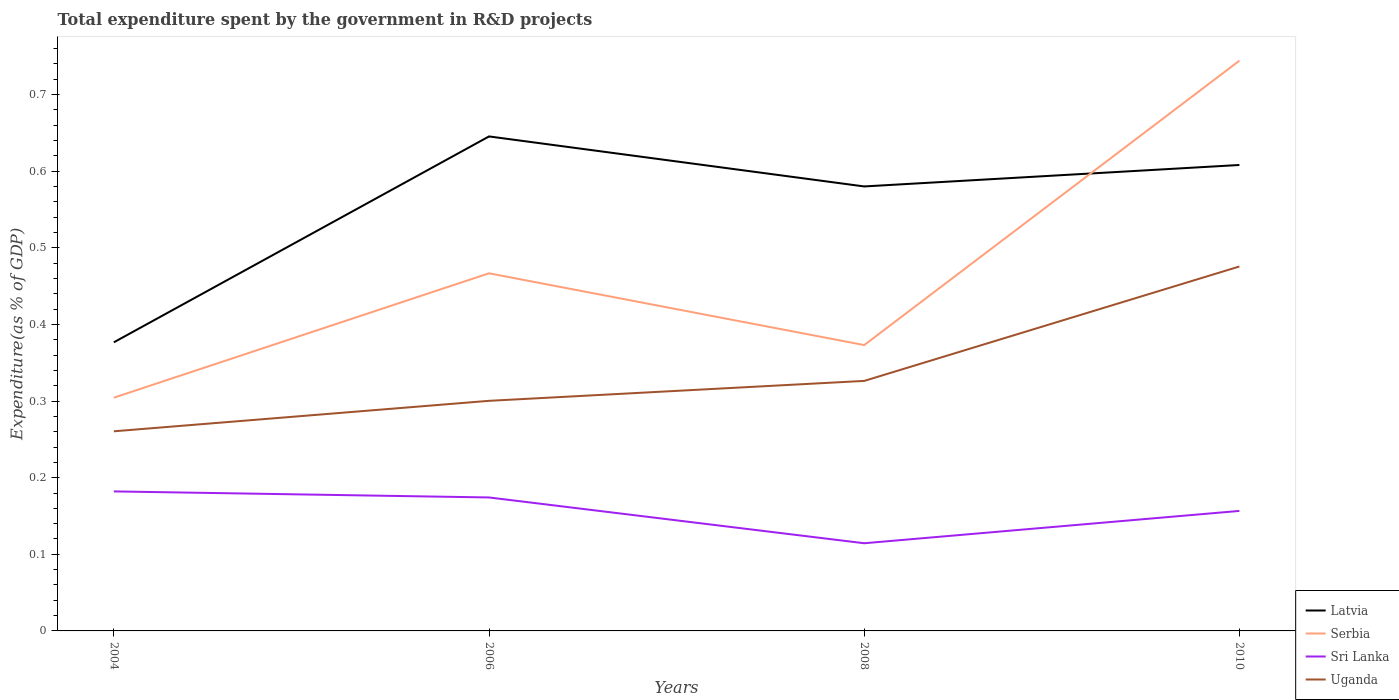How many different coloured lines are there?
Offer a terse response. 4. Does the line corresponding to Serbia intersect with the line corresponding to Latvia?
Provide a short and direct response. Yes. Across all years, what is the maximum total expenditure spent by the government in R&D projects in Serbia?
Make the answer very short. 0.3. What is the total total expenditure spent by the government in R&D projects in Uganda in the graph?
Provide a short and direct response. -0.15. What is the difference between the highest and the second highest total expenditure spent by the government in R&D projects in Serbia?
Offer a very short reply. 0.44. How many lines are there?
Give a very brief answer. 4. How many years are there in the graph?
Your response must be concise. 4. What is the difference between two consecutive major ticks on the Y-axis?
Give a very brief answer. 0.1. Are the values on the major ticks of Y-axis written in scientific E-notation?
Ensure brevity in your answer.  No. Does the graph contain any zero values?
Your answer should be very brief. No. Does the graph contain grids?
Offer a terse response. No. How many legend labels are there?
Your answer should be compact. 4. What is the title of the graph?
Your answer should be compact. Total expenditure spent by the government in R&D projects. Does "Guyana" appear as one of the legend labels in the graph?
Give a very brief answer. No. What is the label or title of the X-axis?
Your answer should be compact. Years. What is the label or title of the Y-axis?
Ensure brevity in your answer.  Expenditure(as % of GDP). What is the Expenditure(as % of GDP) of Latvia in 2004?
Your response must be concise. 0.38. What is the Expenditure(as % of GDP) of Serbia in 2004?
Ensure brevity in your answer.  0.3. What is the Expenditure(as % of GDP) of Sri Lanka in 2004?
Offer a terse response. 0.18. What is the Expenditure(as % of GDP) of Uganda in 2004?
Offer a very short reply. 0.26. What is the Expenditure(as % of GDP) in Latvia in 2006?
Offer a very short reply. 0.65. What is the Expenditure(as % of GDP) of Serbia in 2006?
Make the answer very short. 0.47. What is the Expenditure(as % of GDP) in Sri Lanka in 2006?
Your answer should be compact. 0.17. What is the Expenditure(as % of GDP) in Uganda in 2006?
Your answer should be compact. 0.3. What is the Expenditure(as % of GDP) in Latvia in 2008?
Provide a succinct answer. 0.58. What is the Expenditure(as % of GDP) of Serbia in 2008?
Offer a very short reply. 0.37. What is the Expenditure(as % of GDP) of Sri Lanka in 2008?
Offer a terse response. 0.11. What is the Expenditure(as % of GDP) of Uganda in 2008?
Provide a short and direct response. 0.33. What is the Expenditure(as % of GDP) in Latvia in 2010?
Provide a short and direct response. 0.61. What is the Expenditure(as % of GDP) in Serbia in 2010?
Offer a very short reply. 0.74. What is the Expenditure(as % of GDP) in Sri Lanka in 2010?
Give a very brief answer. 0.16. What is the Expenditure(as % of GDP) in Uganda in 2010?
Your answer should be compact. 0.48. Across all years, what is the maximum Expenditure(as % of GDP) in Latvia?
Your answer should be very brief. 0.65. Across all years, what is the maximum Expenditure(as % of GDP) in Serbia?
Give a very brief answer. 0.74. Across all years, what is the maximum Expenditure(as % of GDP) in Sri Lanka?
Provide a succinct answer. 0.18. Across all years, what is the maximum Expenditure(as % of GDP) in Uganda?
Your response must be concise. 0.48. Across all years, what is the minimum Expenditure(as % of GDP) of Latvia?
Offer a very short reply. 0.38. Across all years, what is the minimum Expenditure(as % of GDP) of Serbia?
Your response must be concise. 0.3. Across all years, what is the minimum Expenditure(as % of GDP) in Sri Lanka?
Make the answer very short. 0.11. Across all years, what is the minimum Expenditure(as % of GDP) of Uganda?
Your answer should be very brief. 0.26. What is the total Expenditure(as % of GDP) of Latvia in the graph?
Offer a terse response. 2.21. What is the total Expenditure(as % of GDP) of Serbia in the graph?
Offer a terse response. 1.89. What is the total Expenditure(as % of GDP) in Sri Lanka in the graph?
Offer a very short reply. 0.63. What is the total Expenditure(as % of GDP) of Uganda in the graph?
Give a very brief answer. 1.36. What is the difference between the Expenditure(as % of GDP) of Latvia in 2004 and that in 2006?
Keep it short and to the point. -0.27. What is the difference between the Expenditure(as % of GDP) in Serbia in 2004 and that in 2006?
Offer a very short reply. -0.16. What is the difference between the Expenditure(as % of GDP) in Sri Lanka in 2004 and that in 2006?
Keep it short and to the point. 0.01. What is the difference between the Expenditure(as % of GDP) of Uganda in 2004 and that in 2006?
Offer a very short reply. -0.04. What is the difference between the Expenditure(as % of GDP) of Latvia in 2004 and that in 2008?
Offer a very short reply. -0.2. What is the difference between the Expenditure(as % of GDP) of Serbia in 2004 and that in 2008?
Provide a succinct answer. -0.07. What is the difference between the Expenditure(as % of GDP) of Sri Lanka in 2004 and that in 2008?
Your answer should be compact. 0.07. What is the difference between the Expenditure(as % of GDP) of Uganda in 2004 and that in 2008?
Ensure brevity in your answer.  -0.07. What is the difference between the Expenditure(as % of GDP) of Latvia in 2004 and that in 2010?
Ensure brevity in your answer.  -0.23. What is the difference between the Expenditure(as % of GDP) in Serbia in 2004 and that in 2010?
Keep it short and to the point. -0.44. What is the difference between the Expenditure(as % of GDP) of Sri Lanka in 2004 and that in 2010?
Your response must be concise. 0.03. What is the difference between the Expenditure(as % of GDP) in Uganda in 2004 and that in 2010?
Offer a terse response. -0.22. What is the difference between the Expenditure(as % of GDP) in Latvia in 2006 and that in 2008?
Offer a very short reply. 0.07. What is the difference between the Expenditure(as % of GDP) of Serbia in 2006 and that in 2008?
Your response must be concise. 0.09. What is the difference between the Expenditure(as % of GDP) of Sri Lanka in 2006 and that in 2008?
Your response must be concise. 0.06. What is the difference between the Expenditure(as % of GDP) of Uganda in 2006 and that in 2008?
Your response must be concise. -0.03. What is the difference between the Expenditure(as % of GDP) of Latvia in 2006 and that in 2010?
Offer a very short reply. 0.04. What is the difference between the Expenditure(as % of GDP) in Serbia in 2006 and that in 2010?
Your answer should be compact. -0.28. What is the difference between the Expenditure(as % of GDP) in Sri Lanka in 2006 and that in 2010?
Keep it short and to the point. 0.02. What is the difference between the Expenditure(as % of GDP) in Uganda in 2006 and that in 2010?
Offer a very short reply. -0.18. What is the difference between the Expenditure(as % of GDP) of Latvia in 2008 and that in 2010?
Provide a succinct answer. -0.03. What is the difference between the Expenditure(as % of GDP) in Serbia in 2008 and that in 2010?
Your answer should be compact. -0.37. What is the difference between the Expenditure(as % of GDP) of Sri Lanka in 2008 and that in 2010?
Make the answer very short. -0.04. What is the difference between the Expenditure(as % of GDP) in Uganda in 2008 and that in 2010?
Provide a short and direct response. -0.15. What is the difference between the Expenditure(as % of GDP) of Latvia in 2004 and the Expenditure(as % of GDP) of Serbia in 2006?
Your response must be concise. -0.09. What is the difference between the Expenditure(as % of GDP) in Latvia in 2004 and the Expenditure(as % of GDP) in Sri Lanka in 2006?
Your response must be concise. 0.2. What is the difference between the Expenditure(as % of GDP) in Latvia in 2004 and the Expenditure(as % of GDP) in Uganda in 2006?
Ensure brevity in your answer.  0.08. What is the difference between the Expenditure(as % of GDP) in Serbia in 2004 and the Expenditure(as % of GDP) in Sri Lanka in 2006?
Give a very brief answer. 0.13. What is the difference between the Expenditure(as % of GDP) in Serbia in 2004 and the Expenditure(as % of GDP) in Uganda in 2006?
Ensure brevity in your answer.  0. What is the difference between the Expenditure(as % of GDP) in Sri Lanka in 2004 and the Expenditure(as % of GDP) in Uganda in 2006?
Offer a very short reply. -0.12. What is the difference between the Expenditure(as % of GDP) in Latvia in 2004 and the Expenditure(as % of GDP) in Serbia in 2008?
Your answer should be very brief. 0. What is the difference between the Expenditure(as % of GDP) in Latvia in 2004 and the Expenditure(as % of GDP) in Sri Lanka in 2008?
Give a very brief answer. 0.26. What is the difference between the Expenditure(as % of GDP) in Latvia in 2004 and the Expenditure(as % of GDP) in Uganda in 2008?
Provide a short and direct response. 0.05. What is the difference between the Expenditure(as % of GDP) in Serbia in 2004 and the Expenditure(as % of GDP) in Sri Lanka in 2008?
Your answer should be compact. 0.19. What is the difference between the Expenditure(as % of GDP) of Serbia in 2004 and the Expenditure(as % of GDP) of Uganda in 2008?
Your answer should be very brief. -0.02. What is the difference between the Expenditure(as % of GDP) of Sri Lanka in 2004 and the Expenditure(as % of GDP) of Uganda in 2008?
Offer a very short reply. -0.14. What is the difference between the Expenditure(as % of GDP) of Latvia in 2004 and the Expenditure(as % of GDP) of Serbia in 2010?
Your answer should be compact. -0.37. What is the difference between the Expenditure(as % of GDP) in Latvia in 2004 and the Expenditure(as % of GDP) in Sri Lanka in 2010?
Offer a very short reply. 0.22. What is the difference between the Expenditure(as % of GDP) in Latvia in 2004 and the Expenditure(as % of GDP) in Uganda in 2010?
Your answer should be compact. -0.1. What is the difference between the Expenditure(as % of GDP) in Serbia in 2004 and the Expenditure(as % of GDP) in Sri Lanka in 2010?
Give a very brief answer. 0.15. What is the difference between the Expenditure(as % of GDP) in Serbia in 2004 and the Expenditure(as % of GDP) in Uganda in 2010?
Your answer should be compact. -0.17. What is the difference between the Expenditure(as % of GDP) of Sri Lanka in 2004 and the Expenditure(as % of GDP) of Uganda in 2010?
Your answer should be very brief. -0.29. What is the difference between the Expenditure(as % of GDP) in Latvia in 2006 and the Expenditure(as % of GDP) in Serbia in 2008?
Provide a succinct answer. 0.27. What is the difference between the Expenditure(as % of GDP) in Latvia in 2006 and the Expenditure(as % of GDP) in Sri Lanka in 2008?
Make the answer very short. 0.53. What is the difference between the Expenditure(as % of GDP) in Latvia in 2006 and the Expenditure(as % of GDP) in Uganda in 2008?
Your answer should be very brief. 0.32. What is the difference between the Expenditure(as % of GDP) of Serbia in 2006 and the Expenditure(as % of GDP) of Sri Lanka in 2008?
Keep it short and to the point. 0.35. What is the difference between the Expenditure(as % of GDP) in Serbia in 2006 and the Expenditure(as % of GDP) in Uganda in 2008?
Offer a terse response. 0.14. What is the difference between the Expenditure(as % of GDP) in Sri Lanka in 2006 and the Expenditure(as % of GDP) in Uganda in 2008?
Keep it short and to the point. -0.15. What is the difference between the Expenditure(as % of GDP) of Latvia in 2006 and the Expenditure(as % of GDP) of Serbia in 2010?
Ensure brevity in your answer.  -0.1. What is the difference between the Expenditure(as % of GDP) of Latvia in 2006 and the Expenditure(as % of GDP) of Sri Lanka in 2010?
Provide a succinct answer. 0.49. What is the difference between the Expenditure(as % of GDP) in Latvia in 2006 and the Expenditure(as % of GDP) in Uganda in 2010?
Offer a very short reply. 0.17. What is the difference between the Expenditure(as % of GDP) of Serbia in 2006 and the Expenditure(as % of GDP) of Sri Lanka in 2010?
Ensure brevity in your answer.  0.31. What is the difference between the Expenditure(as % of GDP) in Serbia in 2006 and the Expenditure(as % of GDP) in Uganda in 2010?
Provide a succinct answer. -0.01. What is the difference between the Expenditure(as % of GDP) in Sri Lanka in 2006 and the Expenditure(as % of GDP) in Uganda in 2010?
Your answer should be compact. -0.3. What is the difference between the Expenditure(as % of GDP) of Latvia in 2008 and the Expenditure(as % of GDP) of Serbia in 2010?
Your answer should be very brief. -0.16. What is the difference between the Expenditure(as % of GDP) in Latvia in 2008 and the Expenditure(as % of GDP) in Sri Lanka in 2010?
Ensure brevity in your answer.  0.42. What is the difference between the Expenditure(as % of GDP) of Latvia in 2008 and the Expenditure(as % of GDP) of Uganda in 2010?
Provide a succinct answer. 0.1. What is the difference between the Expenditure(as % of GDP) of Serbia in 2008 and the Expenditure(as % of GDP) of Sri Lanka in 2010?
Your response must be concise. 0.22. What is the difference between the Expenditure(as % of GDP) of Serbia in 2008 and the Expenditure(as % of GDP) of Uganda in 2010?
Give a very brief answer. -0.1. What is the difference between the Expenditure(as % of GDP) in Sri Lanka in 2008 and the Expenditure(as % of GDP) in Uganda in 2010?
Ensure brevity in your answer.  -0.36. What is the average Expenditure(as % of GDP) in Latvia per year?
Your answer should be compact. 0.55. What is the average Expenditure(as % of GDP) of Serbia per year?
Your answer should be compact. 0.47. What is the average Expenditure(as % of GDP) in Sri Lanka per year?
Your answer should be compact. 0.16. What is the average Expenditure(as % of GDP) of Uganda per year?
Your answer should be very brief. 0.34. In the year 2004, what is the difference between the Expenditure(as % of GDP) in Latvia and Expenditure(as % of GDP) in Serbia?
Your answer should be very brief. 0.07. In the year 2004, what is the difference between the Expenditure(as % of GDP) of Latvia and Expenditure(as % of GDP) of Sri Lanka?
Your answer should be very brief. 0.19. In the year 2004, what is the difference between the Expenditure(as % of GDP) of Latvia and Expenditure(as % of GDP) of Uganda?
Keep it short and to the point. 0.12. In the year 2004, what is the difference between the Expenditure(as % of GDP) of Serbia and Expenditure(as % of GDP) of Sri Lanka?
Your answer should be very brief. 0.12. In the year 2004, what is the difference between the Expenditure(as % of GDP) in Serbia and Expenditure(as % of GDP) in Uganda?
Make the answer very short. 0.04. In the year 2004, what is the difference between the Expenditure(as % of GDP) of Sri Lanka and Expenditure(as % of GDP) of Uganda?
Provide a succinct answer. -0.08. In the year 2006, what is the difference between the Expenditure(as % of GDP) of Latvia and Expenditure(as % of GDP) of Serbia?
Your answer should be very brief. 0.18. In the year 2006, what is the difference between the Expenditure(as % of GDP) in Latvia and Expenditure(as % of GDP) in Sri Lanka?
Give a very brief answer. 0.47. In the year 2006, what is the difference between the Expenditure(as % of GDP) of Latvia and Expenditure(as % of GDP) of Uganda?
Your response must be concise. 0.35. In the year 2006, what is the difference between the Expenditure(as % of GDP) of Serbia and Expenditure(as % of GDP) of Sri Lanka?
Your answer should be very brief. 0.29. In the year 2006, what is the difference between the Expenditure(as % of GDP) of Serbia and Expenditure(as % of GDP) of Uganda?
Provide a succinct answer. 0.17. In the year 2006, what is the difference between the Expenditure(as % of GDP) in Sri Lanka and Expenditure(as % of GDP) in Uganda?
Offer a terse response. -0.13. In the year 2008, what is the difference between the Expenditure(as % of GDP) in Latvia and Expenditure(as % of GDP) in Serbia?
Make the answer very short. 0.21. In the year 2008, what is the difference between the Expenditure(as % of GDP) of Latvia and Expenditure(as % of GDP) of Sri Lanka?
Ensure brevity in your answer.  0.47. In the year 2008, what is the difference between the Expenditure(as % of GDP) of Latvia and Expenditure(as % of GDP) of Uganda?
Your response must be concise. 0.25. In the year 2008, what is the difference between the Expenditure(as % of GDP) of Serbia and Expenditure(as % of GDP) of Sri Lanka?
Ensure brevity in your answer.  0.26. In the year 2008, what is the difference between the Expenditure(as % of GDP) of Serbia and Expenditure(as % of GDP) of Uganda?
Give a very brief answer. 0.05. In the year 2008, what is the difference between the Expenditure(as % of GDP) in Sri Lanka and Expenditure(as % of GDP) in Uganda?
Make the answer very short. -0.21. In the year 2010, what is the difference between the Expenditure(as % of GDP) of Latvia and Expenditure(as % of GDP) of Serbia?
Your answer should be very brief. -0.14. In the year 2010, what is the difference between the Expenditure(as % of GDP) of Latvia and Expenditure(as % of GDP) of Sri Lanka?
Provide a short and direct response. 0.45. In the year 2010, what is the difference between the Expenditure(as % of GDP) of Latvia and Expenditure(as % of GDP) of Uganda?
Ensure brevity in your answer.  0.13. In the year 2010, what is the difference between the Expenditure(as % of GDP) of Serbia and Expenditure(as % of GDP) of Sri Lanka?
Keep it short and to the point. 0.59. In the year 2010, what is the difference between the Expenditure(as % of GDP) in Serbia and Expenditure(as % of GDP) in Uganda?
Offer a terse response. 0.27. In the year 2010, what is the difference between the Expenditure(as % of GDP) of Sri Lanka and Expenditure(as % of GDP) of Uganda?
Provide a succinct answer. -0.32. What is the ratio of the Expenditure(as % of GDP) in Latvia in 2004 to that in 2006?
Ensure brevity in your answer.  0.58. What is the ratio of the Expenditure(as % of GDP) in Serbia in 2004 to that in 2006?
Provide a succinct answer. 0.65. What is the ratio of the Expenditure(as % of GDP) of Sri Lanka in 2004 to that in 2006?
Give a very brief answer. 1.05. What is the ratio of the Expenditure(as % of GDP) in Uganda in 2004 to that in 2006?
Make the answer very short. 0.87. What is the ratio of the Expenditure(as % of GDP) in Latvia in 2004 to that in 2008?
Your answer should be very brief. 0.65. What is the ratio of the Expenditure(as % of GDP) in Serbia in 2004 to that in 2008?
Offer a terse response. 0.82. What is the ratio of the Expenditure(as % of GDP) of Sri Lanka in 2004 to that in 2008?
Your response must be concise. 1.59. What is the ratio of the Expenditure(as % of GDP) of Uganda in 2004 to that in 2008?
Keep it short and to the point. 0.8. What is the ratio of the Expenditure(as % of GDP) in Latvia in 2004 to that in 2010?
Your response must be concise. 0.62. What is the ratio of the Expenditure(as % of GDP) in Serbia in 2004 to that in 2010?
Offer a terse response. 0.41. What is the ratio of the Expenditure(as % of GDP) in Sri Lanka in 2004 to that in 2010?
Offer a terse response. 1.16. What is the ratio of the Expenditure(as % of GDP) in Uganda in 2004 to that in 2010?
Make the answer very short. 0.55. What is the ratio of the Expenditure(as % of GDP) of Latvia in 2006 to that in 2008?
Offer a very short reply. 1.11. What is the ratio of the Expenditure(as % of GDP) in Serbia in 2006 to that in 2008?
Keep it short and to the point. 1.25. What is the ratio of the Expenditure(as % of GDP) in Sri Lanka in 2006 to that in 2008?
Give a very brief answer. 1.52. What is the ratio of the Expenditure(as % of GDP) of Uganda in 2006 to that in 2008?
Offer a terse response. 0.92. What is the ratio of the Expenditure(as % of GDP) in Latvia in 2006 to that in 2010?
Your response must be concise. 1.06. What is the ratio of the Expenditure(as % of GDP) in Serbia in 2006 to that in 2010?
Offer a very short reply. 0.63. What is the ratio of the Expenditure(as % of GDP) in Sri Lanka in 2006 to that in 2010?
Your answer should be compact. 1.11. What is the ratio of the Expenditure(as % of GDP) of Uganda in 2006 to that in 2010?
Your answer should be compact. 0.63. What is the ratio of the Expenditure(as % of GDP) in Latvia in 2008 to that in 2010?
Give a very brief answer. 0.95. What is the ratio of the Expenditure(as % of GDP) of Serbia in 2008 to that in 2010?
Your answer should be compact. 0.5. What is the ratio of the Expenditure(as % of GDP) of Sri Lanka in 2008 to that in 2010?
Your answer should be compact. 0.73. What is the ratio of the Expenditure(as % of GDP) in Uganda in 2008 to that in 2010?
Give a very brief answer. 0.69. What is the difference between the highest and the second highest Expenditure(as % of GDP) of Latvia?
Provide a short and direct response. 0.04. What is the difference between the highest and the second highest Expenditure(as % of GDP) in Serbia?
Give a very brief answer. 0.28. What is the difference between the highest and the second highest Expenditure(as % of GDP) of Sri Lanka?
Your answer should be very brief. 0.01. What is the difference between the highest and the second highest Expenditure(as % of GDP) of Uganda?
Your response must be concise. 0.15. What is the difference between the highest and the lowest Expenditure(as % of GDP) in Latvia?
Offer a terse response. 0.27. What is the difference between the highest and the lowest Expenditure(as % of GDP) of Serbia?
Make the answer very short. 0.44. What is the difference between the highest and the lowest Expenditure(as % of GDP) in Sri Lanka?
Provide a succinct answer. 0.07. What is the difference between the highest and the lowest Expenditure(as % of GDP) of Uganda?
Your answer should be very brief. 0.22. 